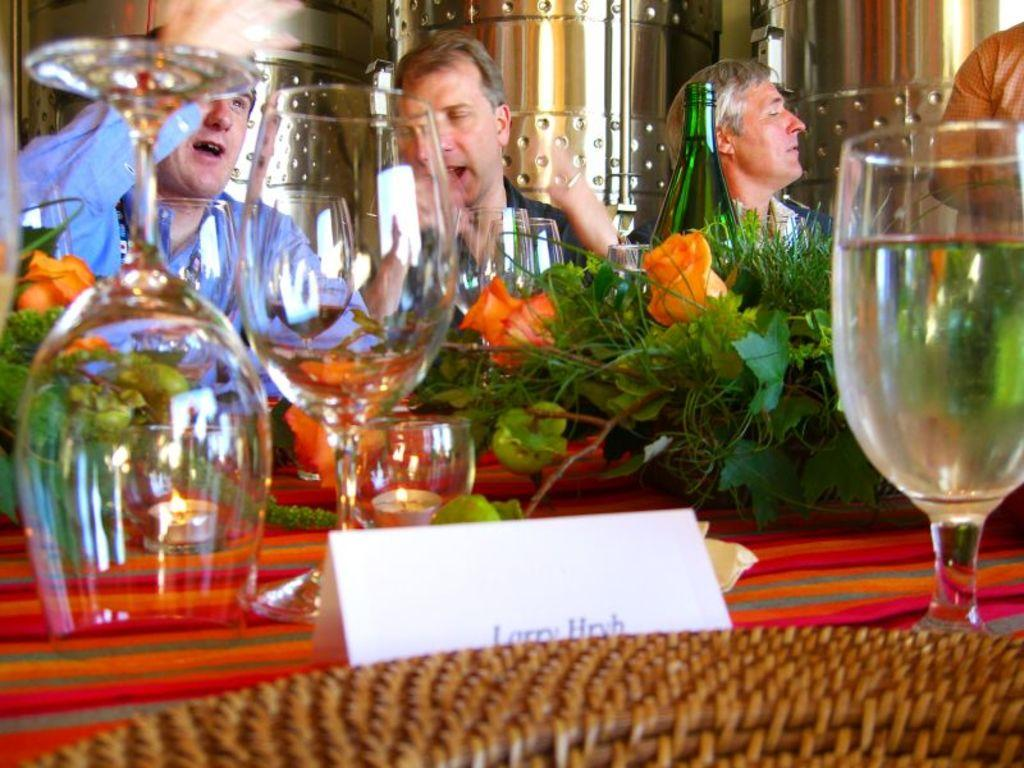How many people are present in the image? There are people in the image, but the exact number cannot be determined from the provided facts. What objects can be seen in the image besides people? There are glasses, flower bouquets, a bottle, a name board, and a part of a basket visible in the image. What might the people be holding or using in the image? The people might be holding glasses or the bottle, but the facts do not specify their actions. What is the purpose of the name board in the image? The purpose of the name board in the image cannot be determined from the provided facts. How many cups are visible in the image? There is no mention of cups in the provided facts, so we cannot determine the number of cups in the image. What type of rake is being used by the person in the image? There is no rake present in the image, so we cannot answer this question. 